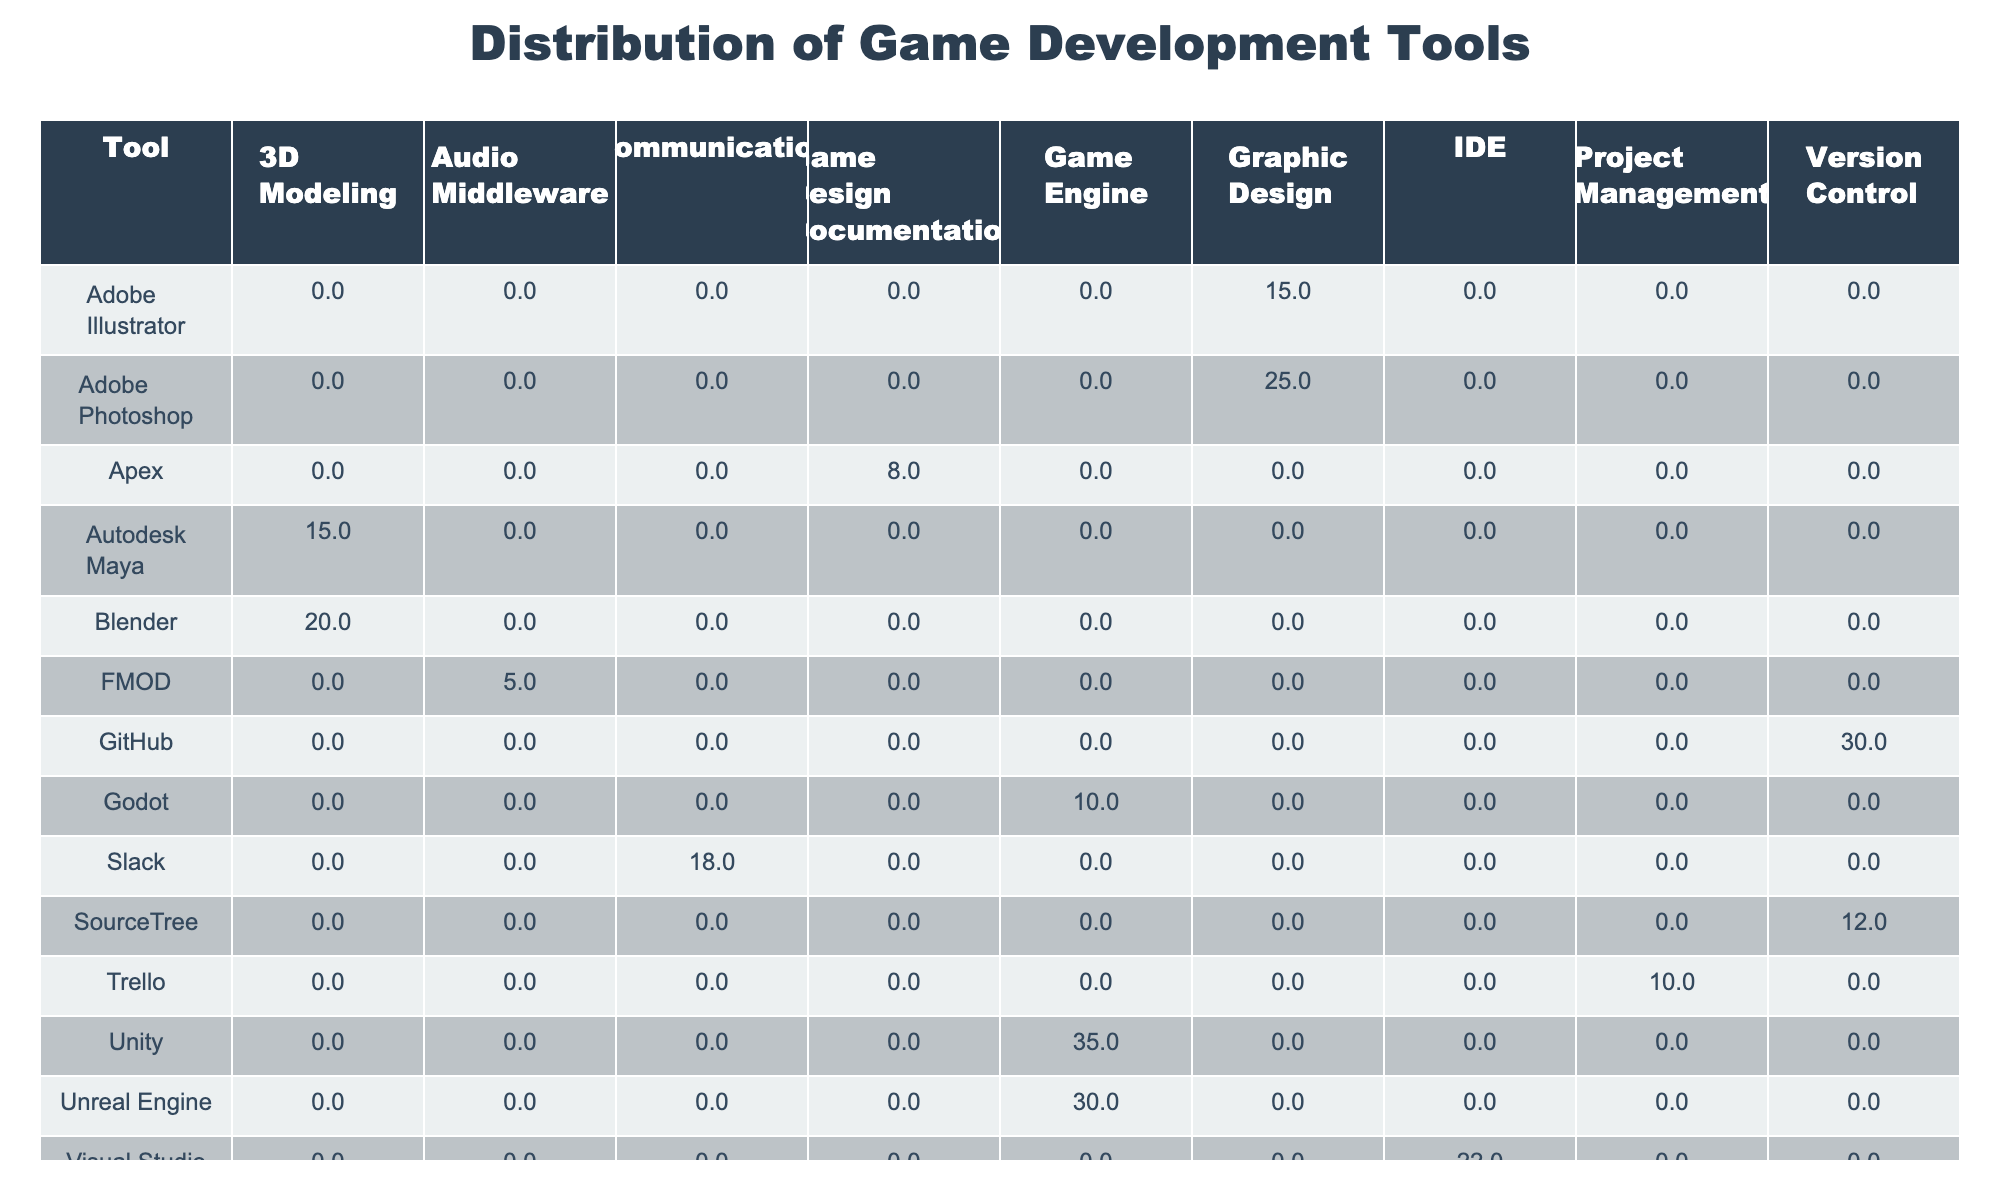What is the usage percentage of Unity? Referring to the table, Unity has a usage percentage of 35% listed under the Game Engine category.
Answer: 35% Which tool has the highest usage percentage among the graphic design tools? The usage percentages for the graphic design tools are Adobe Photoshop at 25% and Adobe Illustrator at 15%. Therefore, Adobe Photoshop has the highest usage percentage among them.
Answer: Adobe Photoshop What is the total usage percentage of all 3D modeling tools? The usage percentages for 3D modeling tools are Blender (20%), Autodesk Maya (15%), and ZBrush (10%). Summing these gives 20 + 15 + 10 = 45%.
Answer: 45% Is Adobe Illustrator used more than Trello? Adobe Illustrator usage percentage is 15%, while Trello has a usage percentage of 10%. Since 15% is greater than 10%, the statement is true.
Answer: Yes What is the average usage percentage of all audio middleware tools listed? The only audio middleware tool listed is FMOD, and its usage percentage is 5%. Therefore, the average usage percentage is also 5% since there is only one tool to consider.
Answer: 5% Which category has the lowest total usage percentage? The categories can be broken down as follows: Game Engine (35 + 30 + 10 = 75%), Graphic Design (25 + 15 = 40%), 3D Modeling (20 + 15 + 10 = 45%), Audio Middleware (5 = 5%), Game Design Documentation (8 = 8%), Project Management (10 = 10%), Communication (18 = 18%), IDE (22 = 22%), and Version Control (12 + 30 = 42%). The lowest total usage percentage is for Audio Middleware at 5%.
Answer: Audio Middleware How much more is the usage percentage of GitHub compared to SourceTree? GitHub has a usage percentage of 30% and SourceTree has 12%. The difference is calculated as 30 - 12 = 18%.
Answer: 18% Which game engine's usage percentage is closest to the average usage percentage of all tools? The average usage percentage can be calculated by summing all the percentages: 35 + 30 + 10 + 25 + 15 + 20 + 15 + 10 + 5 + 8 + 10 + 18 + 22 + 12 + 30 =  220. Dividing by the number of tools (15) gives an average of approximately 14.67%. The tool with the closest percentage is ZBrush at 10%.
Answer: ZBrush How many tools have a usage percentage less than 15%? The tools with usage percentages less than 15% are: Godot (10%), Adobe Illustrator (15% - not counted), FMOD (5%), Apex (8%), ZBrush (10%), Trello (10%), and SourceTree (12%). That gives a total of 4 tools under 15%.
Answer: 4 